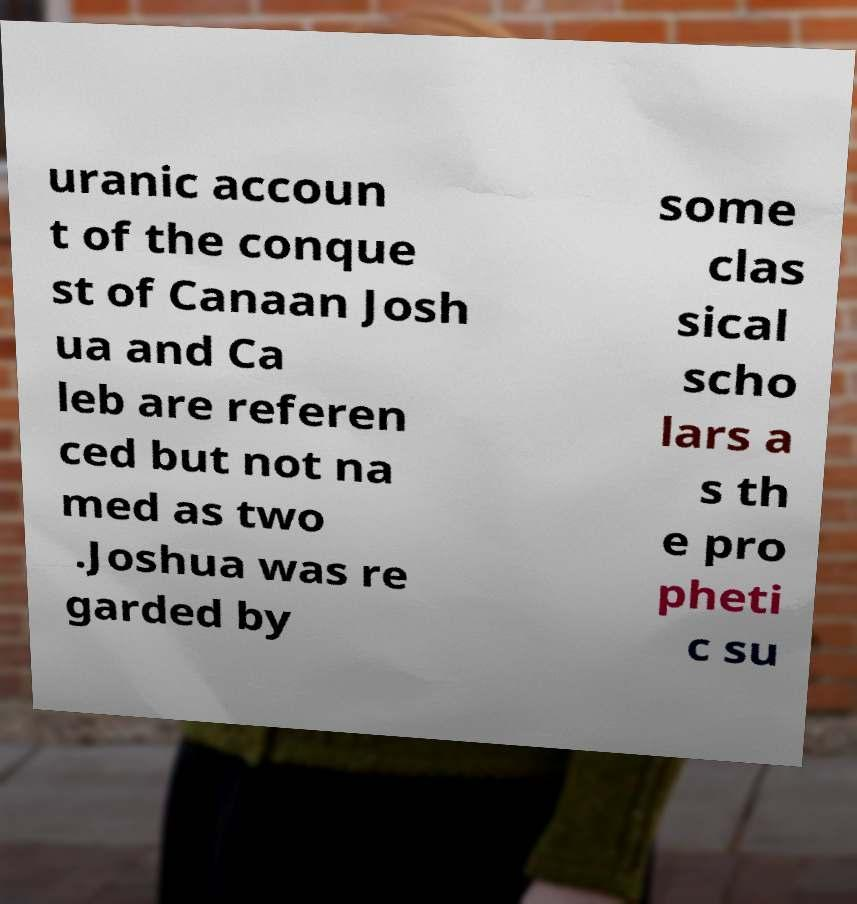Please read and relay the text visible in this image. What does it say? uranic accoun t of the conque st of Canaan Josh ua and Ca leb are referen ced but not na med as two .Joshua was re garded by some clas sical scho lars a s th e pro pheti c su 